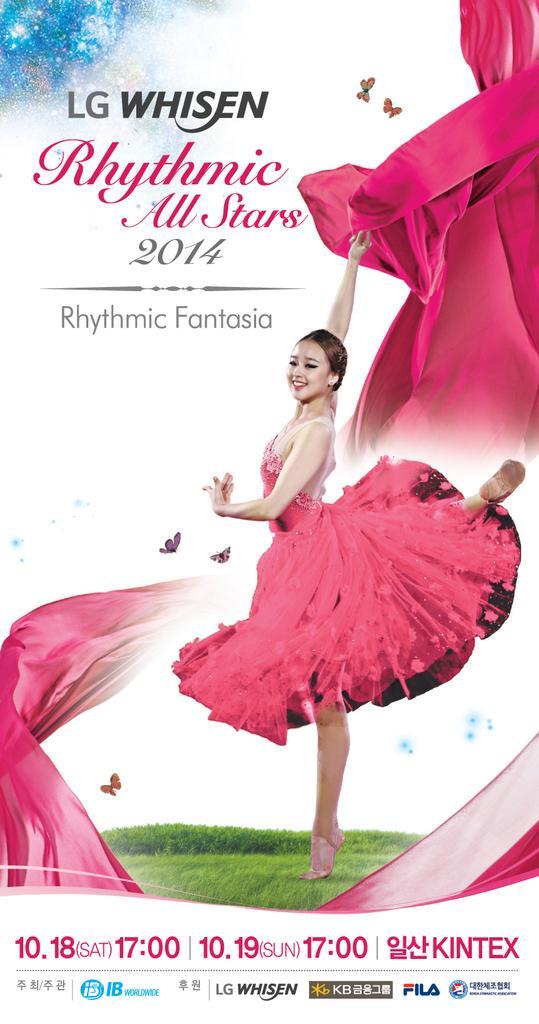How would you summarize this image in a sentence or two? This is an edited image in which there are some text and numbers written on it and there is a image of the woman standing and smiling and holding cloth in her hand. 